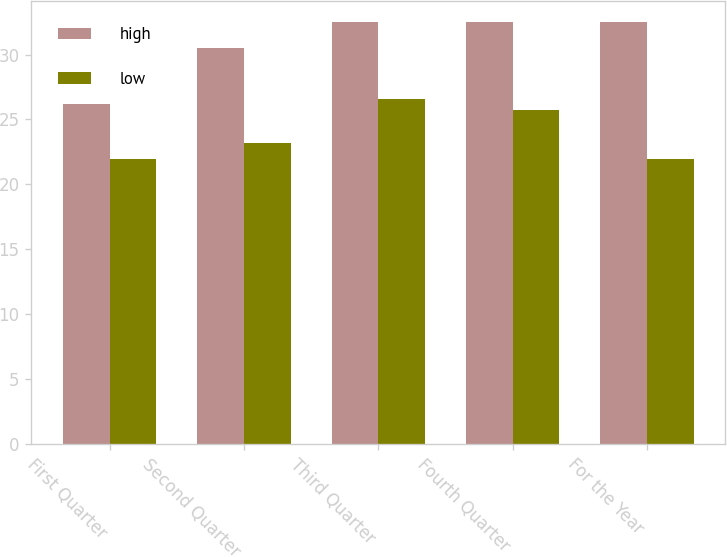Convert chart to OTSL. <chart><loc_0><loc_0><loc_500><loc_500><stacked_bar_chart><ecel><fcel>First Quarter<fcel>Second Quarter<fcel>Third Quarter<fcel>Fourth Quarter<fcel>For the Year<nl><fcel>high<fcel>26.22<fcel>30.5<fcel>32.53<fcel>32.52<fcel>32.53<nl><fcel>low<fcel>21.98<fcel>23.21<fcel>26.54<fcel>25.75<fcel>21.98<nl></chart> 